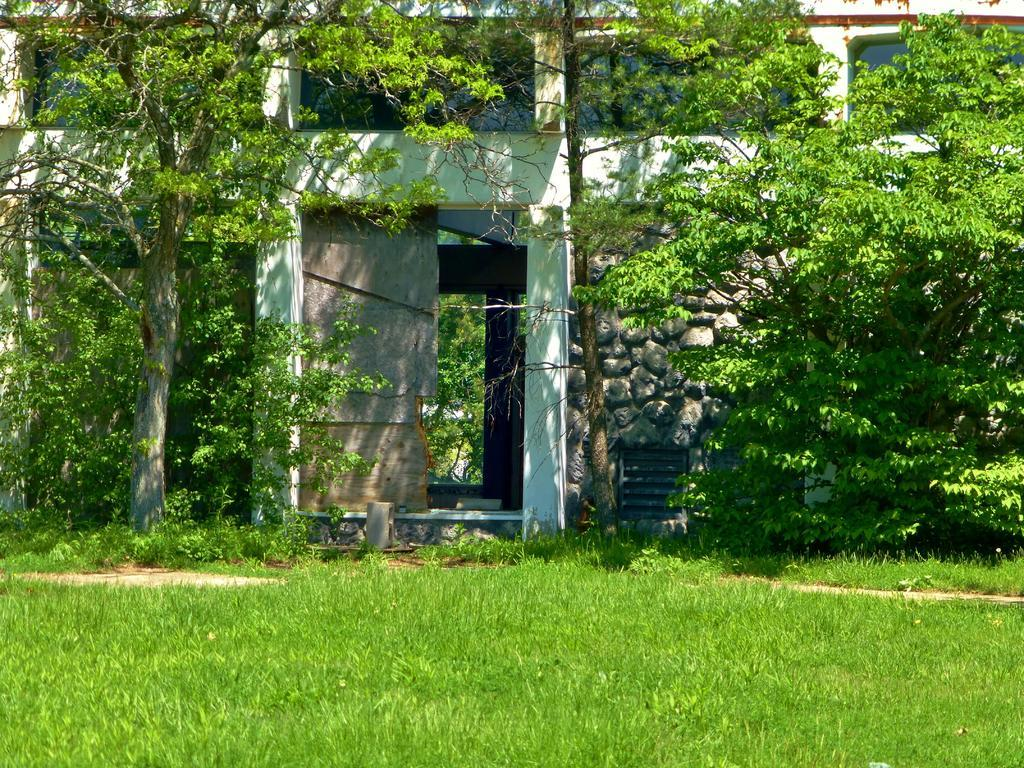What type of landscape is visible in the foreground of the image? The foreground of the image contains grassland. What can be seen in the background of the image? There is a tree and a building in the background of the image. What type of star can be seen shining brightly in the image? There is no star visible in the image; it features a grassland landscape with a tree and a building in the background. 